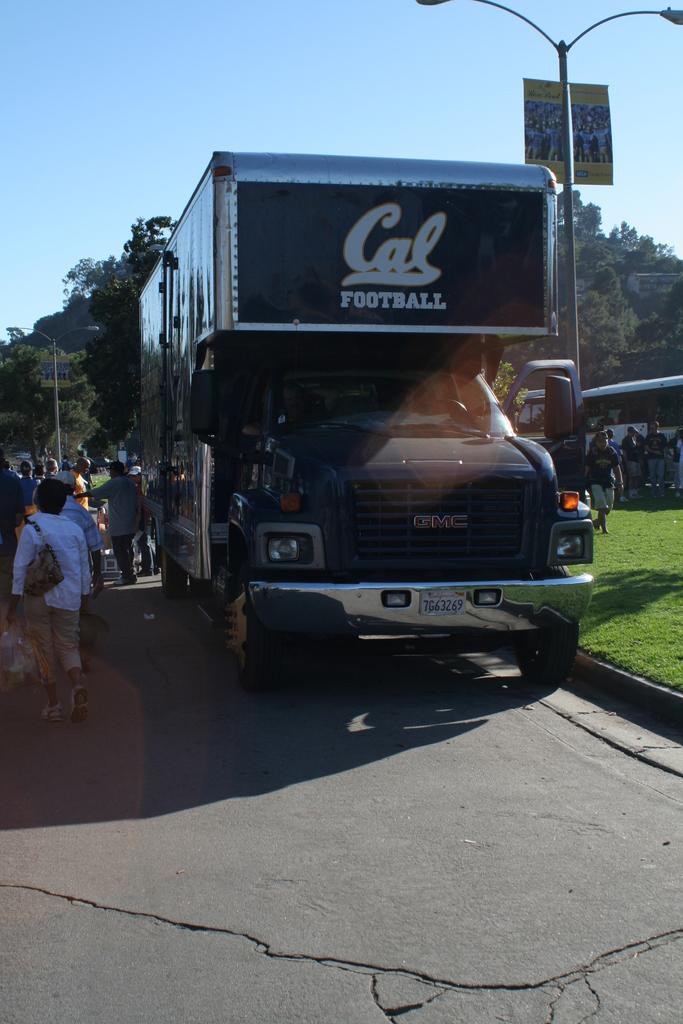What type of motor vehicle is in the image? The image contains a motor vehicle, but the specific type is not mentioned. What are the persons standing on the road doing? The actions of the persons standing on the road are not specified in the image. What can be seen on the ground in the image? The ground is visible in the image, but no specific details are provided. What structure is present in the image? There is a shed in the image. What type of vegetation is in the image? There are trees in the image. What is the purpose of the street pole in the image? The purpose of the street pole is not mentioned in the image. What type of lighting is present in the image? There are street lights in the image. What is visible in the sky in the image? The sky is visible in the image, but no specific details are provided. How many stamps are on the father's forehead in the image? There is no father or stamps present in the image. What type of clothing are the women wearing in the image? There are no women present in the image. 